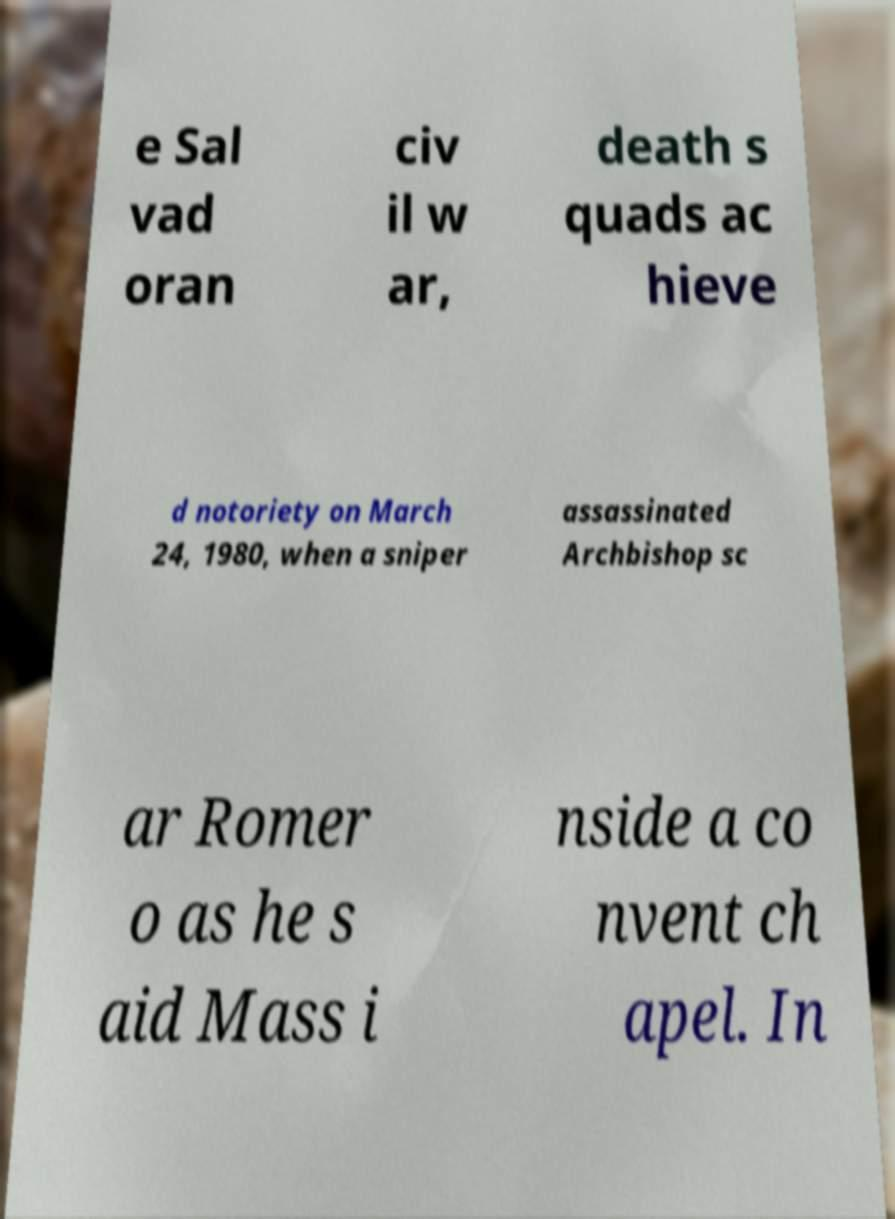I need the written content from this picture converted into text. Can you do that? e Sal vad oran civ il w ar, death s quads ac hieve d notoriety on March 24, 1980, when a sniper assassinated Archbishop sc ar Romer o as he s aid Mass i nside a co nvent ch apel. In 